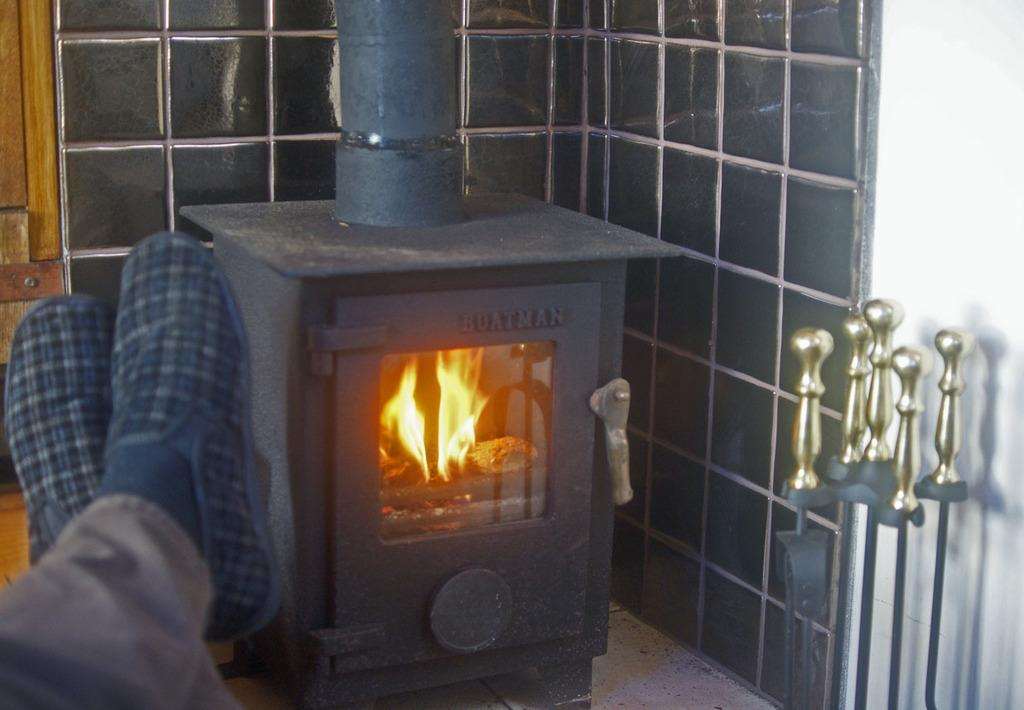What type of stove is shown in the image? There is a wood burning stove in the image. Can you describe any human presence in the image? Human legs are visible on the left side of the image. What material are the rods on the right side of the image made of? Iron rods are present on the right side of the image. What type of board game is being played on the wood burning stove? There is no board game present in the image; it features a wood burning stove, human legs, and iron rods. Can you tell me what kind of humor is being displayed by the dog in the image? There is no dog present in the image. 